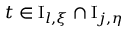<formula> <loc_0><loc_0><loc_500><loc_500>t \in I _ { l , \xi } \cap I _ { j , \eta }</formula> 